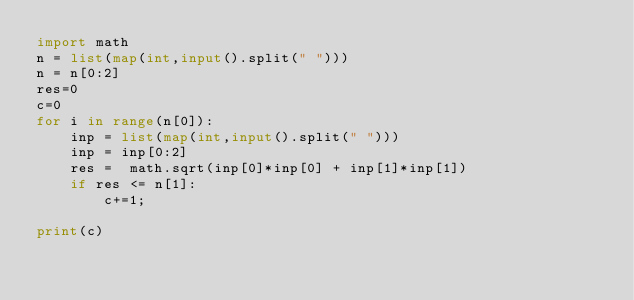Convert code to text. <code><loc_0><loc_0><loc_500><loc_500><_Python_>import math
n = list(map(int,input().split(" ")))
n = n[0:2]
res=0
c=0
for i in range(n[0]):
    inp = list(map(int,input().split(" ")))
    inp = inp[0:2]
    res =  math.sqrt(inp[0]*inp[0] + inp[1]*inp[1])
    if res <= n[1]:
        c+=1;
    
print(c)
</code> 